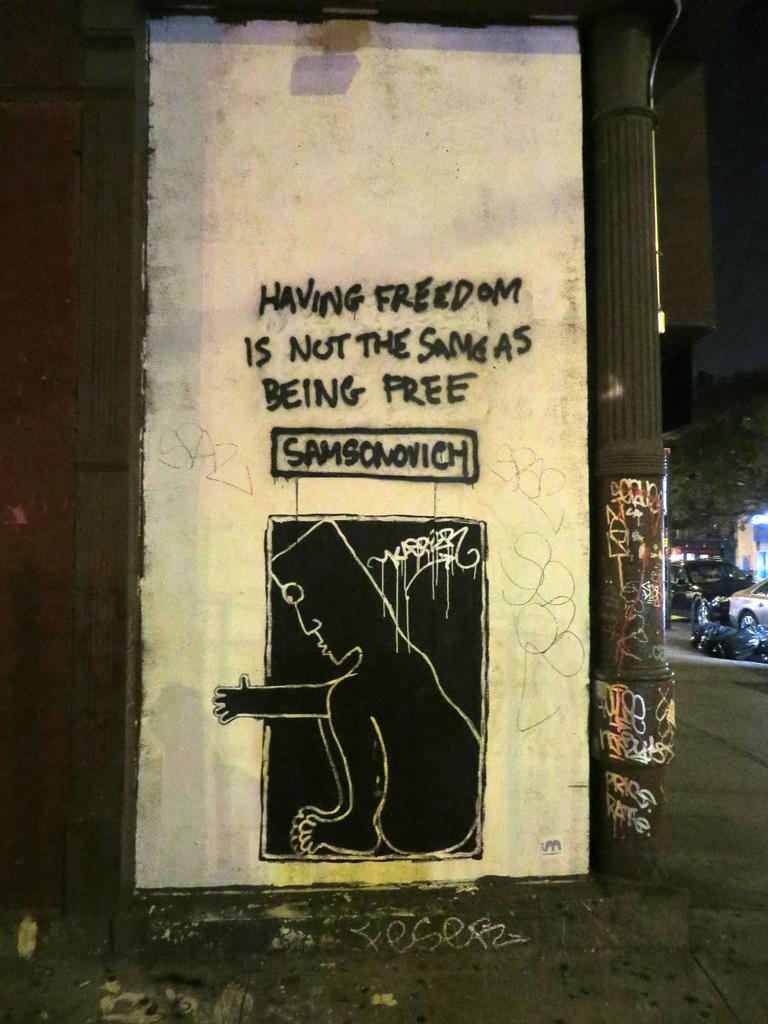What is the main subject of the image? There is an art piece in the image. What is written on the wall in the image? There is text written on a white wall in the image. Can you describe any architectural features in the image? There is a pillar in the image. What can be seen in the background of the image? Vehicles and trees are visible in the background of the image, and the sky is dark. How many ants are crawling on the tray in the image? There is no tray or ants present in the image. 